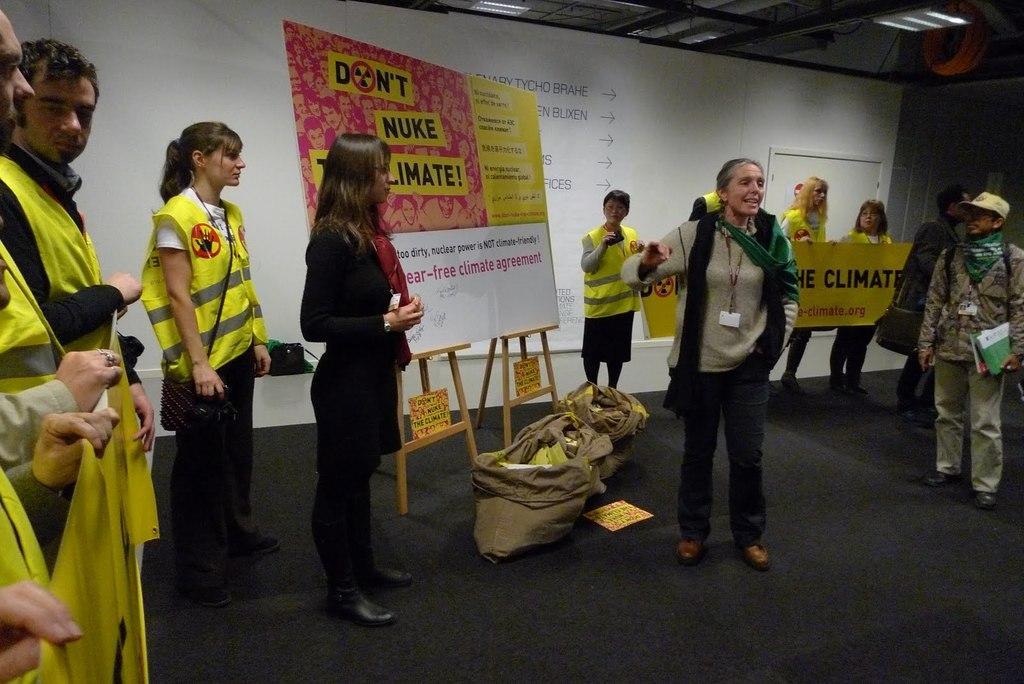Please provide a concise description of this image. In this image I can see people are standing. Here I can see a board, bags and other objects on the floor. In the background I can see a white color wall and a board which has something written on it. 